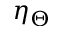<formula> <loc_0><loc_0><loc_500><loc_500>\eta _ { \Theta }</formula> 